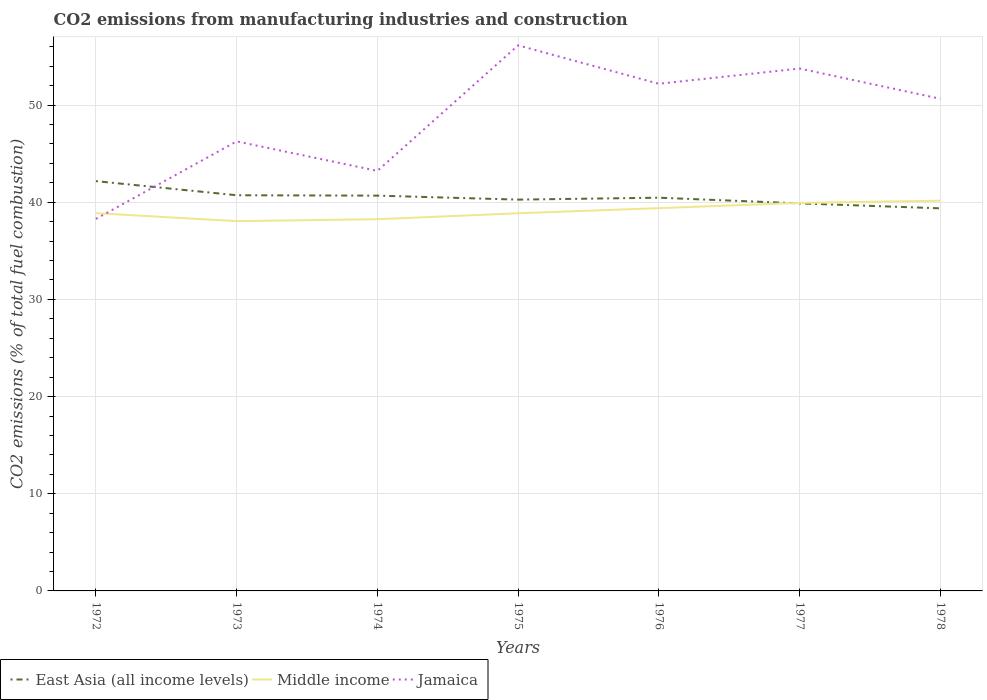How many different coloured lines are there?
Your answer should be very brief. 3. Across all years, what is the maximum amount of CO2 emitted in East Asia (all income levels)?
Offer a terse response. 39.37. In which year was the amount of CO2 emitted in East Asia (all income levels) maximum?
Give a very brief answer. 1978. What is the total amount of CO2 emitted in East Asia (all income levels) in the graph?
Your response must be concise. 0.45. What is the difference between the highest and the second highest amount of CO2 emitted in Jamaica?
Provide a short and direct response. 17.86. What is the difference between the highest and the lowest amount of CO2 emitted in Middle income?
Offer a very short reply. 3. Is the amount of CO2 emitted in Jamaica strictly greater than the amount of CO2 emitted in East Asia (all income levels) over the years?
Make the answer very short. No. How many years are there in the graph?
Ensure brevity in your answer.  7. What is the difference between two consecutive major ticks on the Y-axis?
Make the answer very short. 10. Are the values on the major ticks of Y-axis written in scientific E-notation?
Offer a terse response. No. Does the graph contain grids?
Your response must be concise. Yes. How are the legend labels stacked?
Offer a very short reply. Horizontal. What is the title of the graph?
Ensure brevity in your answer.  CO2 emissions from manufacturing industries and construction. Does "France" appear as one of the legend labels in the graph?
Provide a succinct answer. No. What is the label or title of the Y-axis?
Offer a terse response. CO2 emissions (% of total fuel combustion). What is the CO2 emissions (% of total fuel combustion) of East Asia (all income levels) in 1972?
Offer a terse response. 42.17. What is the CO2 emissions (% of total fuel combustion) in Middle income in 1972?
Give a very brief answer. 38.87. What is the CO2 emissions (% of total fuel combustion) of Jamaica in 1972?
Give a very brief answer. 38.28. What is the CO2 emissions (% of total fuel combustion) in East Asia (all income levels) in 1973?
Provide a short and direct response. 40.72. What is the CO2 emissions (% of total fuel combustion) in Middle income in 1973?
Provide a short and direct response. 38.05. What is the CO2 emissions (% of total fuel combustion) of Jamaica in 1973?
Offer a very short reply. 46.26. What is the CO2 emissions (% of total fuel combustion) in East Asia (all income levels) in 1974?
Your answer should be compact. 40.68. What is the CO2 emissions (% of total fuel combustion) in Middle income in 1974?
Offer a terse response. 38.25. What is the CO2 emissions (% of total fuel combustion) in Jamaica in 1974?
Make the answer very short. 43.22. What is the CO2 emissions (% of total fuel combustion) in East Asia (all income levels) in 1975?
Provide a succinct answer. 40.27. What is the CO2 emissions (% of total fuel combustion) of Middle income in 1975?
Keep it short and to the point. 38.86. What is the CO2 emissions (% of total fuel combustion) in Jamaica in 1975?
Ensure brevity in your answer.  56.14. What is the CO2 emissions (% of total fuel combustion) in East Asia (all income levels) in 1976?
Provide a short and direct response. 40.46. What is the CO2 emissions (% of total fuel combustion) in Middle income in 1976?
Ensure brevity in your answer.  39.39. What is the CO2 emissions (% of total fuel combustion) of Jamaica in 1976?
Your answer should be compact. 52.19. What is the CO2 emissions (% of total fuel combustion) in East Asia (all income levels) in 1977?
Offer a very short reply. 39.88. What is the CO2 emissions (% of total fuel combustion) of Middle income in 1977?
Offer a very short reply. 39.93. What is the CO2 emissions (% of total fuel combustion) of Jamaica in 1977?
Provide a succinct answer. 53.76. What is the CO2 emissions (% of total fuel combustion) of East Asia (all income levels) in 1978?
Keep it short and to the point. 39.37. What is the CO2 emissions (% of total fuel combustion) of Middle income in 1978?
Your response must be concise. 40.16. What is the CO2 emissions (% of total fuel combustion) of Jamaica in 1978?
Provide a short and direct response. 50.65. Across all years, what is the maximum CO2 emissions (% of total fuel combustion) of East Asia (all income levels)?
Make the answer very short. 42.17. Across all years, what is the maximum CO2 emissions (% of total fuel combustion) in Middle income?
Give a very brief answer. 40.16. Across all years, what is the maximum CO2 emissions (% of total fuel combustion) in Jamaica?
Offer a very short reply. 56.14. Across all years, what is the minimum CO2 emissions (% of total fuel combustion) in East Asia (all income levels)?
Keep it short and to the point. 39.37. Across all years, what is the minimum CO2 emissions (% of total fuel combustion) of Middle income?
Keep it short and to the point. 38.05. Across all years, what is the minimum CO2 emissions (% of total fuel combustion) of Jamaica?
Your response must be concise. 38.28. What is the total CO2 emissions (% of total fuel combustion) in East Asia (all income levels) in the graph?
Make the answer very short. 283.55. What is the total CO2 emissions (% of total fuel combustion) in Middle income in the graph?
Your answer should be compact. 273.51. What is the total CO2 emissions (% of total fuel combustion) of Jamaica in the graph?
Keep it short and to the point. 340.5. What is the difference between the CO2 emissions (% of total fuel combustion) of East Asia (all income levels) in 1972 and that in 1973?
Provide a short and direct response. 1.45. What is the difference between the CO2 emissions (% of total fuel combustion) in Middle income in 1972 and that in 1973?
Keep it short and to the point. 0.82. What is the difference between the CO2 emissions (% of total fuel combustion) in Jamaica in 1972 and that in 1973?
Offer a terse response. -7.98. What is the difference between the CO2 emissions (% of total fuel combustion) in East Asia (all income levels) in 1972 and that in 1974?
Offer a very short reply. 1.49. What is the difference between the CO2 emissions (% of total fuel combustion) of Middle income in 1972 and that in 1974?
Your answer should be very brief. 0.62. What is the difference between the CO2 emissions (% of total fuel combustion) of Jamaica in 1972 and that in 1974?
Your response must be concise. -4.94. What is the difference between the CO2 emissions (% of total fuel combustion) of East Asia (all income levels) in 1972 and that in 1975?
Offer a terse response. 1.9. What is the difference between the CO2 emissions (% of total fuel combustion) of Middle income in 1972 and that in 1975?
Make the answer very short. 0.01. What is the difference between the CO2 emissions (% of total fuel combustion) in Jamaica in 1972 and that in 1975?
Ensure brevity in your answer.  -17.86. What is the difference between the CO2 emissions (% of total fuel combustion) in East Asia (all income levels) in 1972 and that in 1976?
Your answer should be very brief. 1.7. What is the difference between the CO2 emissions (% of total fuel combustion) in Middle income in 1972 and that in 1976?
Ensure brevity in your answer.  -0.52. What is the difference between the CO2 emissions (% of total fuel combustion) in Jamaica in 1972 and that in 1976?
Provide a short and direct response. -13.9. What is the difference between the CO2 emissions (% of total fuel combustion) in East Asia (all income levels) in 1972 and that in 1977?
Your response must be concise. 2.29. What is the difference between the CO2 emissions (% of total fuel combustion) of Middle income in 1972 and that in 1977?
Offer a very short reply. -1.06. What is the difference between the CO2 emissions (% of total fuel combustion) in Jamaica in 1972 and that in 1977?
Your response must be concise. -15.47. What is the difference between the CO2 emissions (% of total fuel combustion) of East Asia (all income levels) in 1972 and that in 1978?
Provide a short and direct response. 2.8. What is the difference between the CO2 emissions (% of total fuel combustion) in Middle income in 1972 and that in 1978?
Offer a very short reply. -1.29. What is the difference between the CO2 emissions (% of total fuel combustion) in Jamaica in 1972 and that in 1978?
Offer a very short reply. -12.36. What is the difference between the CO2 emissions (% of total fuel combustion) in East Asia (all income levels) in 1973 and that in 1974?
Keep it short and to the point. 0.04. What is the difference between the CO2 emissions (% of total fuel combustion) of Middle income in 1973 and that in 1974?
Provide a short and direct response. -0.2. What is the difference between the CO2 emissions (% of total fuel combustion) of Jamaica in 1973 and that in 1974?
Provide a succinct answer. 3.03. What is the difference between the CO2 emissions (% of total fuel combustion) in East Asia (all income levels) in 1973 and that in 1975?
Provide a succinct answer. 0.45. What is the difference between the CO2 emissions (% of total fuel combustion) in Middle income in 1973 and that in 1975?
Give a very brief answer. -0.81. What is the difference between the CO2 emissions (% of total fuel combustion) in Jamaica in 1973 and that in 1975?
Your answer should be compact. -9.88. What is the difference between the CO2 emissions (% of total fuel combustion) of East Asia (all income levels) in 1973 and that in 1976?
Give a very brief answer. 0.25. What is the difference between the CO2 emissions (% of total fuel combustion) in Middle income in 1973 and that in 1976?
Your response must be concise. -1.34. What is the difference between the CO2 emissions (% of total fuel combustion) in Jamaica in 1973 and that in 1976?
Give a very brief answer. -5.93. What is the difference between the CO2 emissions (% of total fuel combustion) in East Asia (all income levels) in 1973 and that in 1977?
Offer a terse response. 0.84. What is the difference between the CO2 emissions (% of total fuel combustion) in Middle income in 1973 and that in 1977?
Offer a very short reply. -1.88. What is the difference between the CO2 emissions (% of total fuel combustion) of Jamaica in 1973 and that in 1977?
Give a very brief answer. -7.5. What is the difference between the CO2 emissions (% of total fuel combustion) in East Asia (all income levels) in 1973 and that in 1978?
Keep it short and to the point. 1.35. What is the difference between the CO2 emissions (% of total fuel combustion) of Middle income in 1973 and that in 1978?
Make the answer very short. -2.1. What is the difference between the CO2 emissions (% of total fuel combustion) in Jamaica in 1973 and that in 1978?
Provide a succinct answer. -4.39. What is the difference between the CO2 emissions (% of total fuel combustion) of East Asia (all income levels) in 1974 and that in 1975?
Provide a short and direct response. 0.41. What is the difference between the CO2 emissions (% of total fuel combustion) in Middle income in 1974 and that in 1975?
Offer a terse response. -0.61. What is the difference between the CO2 emissions (% of total fuel combustion) in Jamaica in 1974 and that in 1975?
Give a very brief answer. -12.92. What is the difference between the CO2 emissions (% of total fuel combustion) in East Asia (all income levels) in 1974 and that in 1976?
Your response must be concise. 0.21. What is the difference between the CO2 emissions (% of total fuel combustion) in Middle income in 1974 and that in 1976?
Your response must be concise. -1.14. What is the difference between the CO2 emissions (% of total fuel combustion) in Jamaica in 1974 and that in 1976?
Offer a terse response. -8.96. What is the difference between the CO2 emissions (% of total fuel combustion) in East Asia (all income levels) in 1974 and that in 1977?
Ensure brevity in your answer.  0.8. What is the difference between the CO2 emissions (% of total fuel combustion) of Middle income in 1974 and that in 1977?
Give a very brief answer. -1.68. What is the difference between the CO2 emissions (% of total fuel combustion) of Jamaica in 1974 and that in 1977?
Offer a terse response. -10.53. What is the difference between the CO2 emissions (% of total fuel combustion) in East Asia (all income levels) in 1974 and that in 1978?
Provide a succinct answer. 1.3. What is the difference between the CO2 emissions (% of total fuel combustion) of Middle income in 1974 and that in 1978?
Your response must be concise. -1.91. What is the difference between the CO2 emissions (% of total fuel combustion) in Jamaica in 1974 and that in 1978?
Give a very brief answer. -7.42. What is the difference between the CO2 emissions (% of total fuel combustion) of East Asia (all income levels) in 1975 and that in 1976?
Your answer should be very brief. -0.2. What is the difference between the CO2 emissions (% of total fuel combustion) of Middle income in 1975 and that in 1976?
Make the answer very short. -0.53. What is the difference between the CO2 emissions (% of total fuel combustion) in Jamaica in 1975 and that in 1976?
Ensure brevity in your answer.  3.95. What is the difference between the CO2 emissions (% of total fuel combustion) in East Asia (all income levels) in 1975 and that in 1977?
Offer a very short reply. 0.39. What is the difference between the CO2 emissions (% of total fuel combustion) in Middle income in 1975 and that in 1977?
Your response must be concise. -1.07. What is the difference between the CO2 emissions (% of total fuel combustion) of Jamaica in 1975 and that in 1977?
Offer a terse response. 2.38. What is the difference between the CO2 emissions (% of total fuel combustion) in East Asia (all income levels) in 1975 and that in 1978?
Offer a terse response. 0.9. What is the difference between the CO2 emissions (% of total fuel combustion) of Middle income in 1975 and that in 1978?
Keep it short and to the point. -1.3. What is the difference between the CO2 emissions (% of total fuel combustion) of Jamaica in 1975 and that in 1978?
Offer a terse response. 5.49. What is the difference between the CO2 emissions (% of total fuel combustion) in East Asia (all income levels) in 1976 and that in 1977?
Ensure brevity in your answer.  0.58. What is the difference between the CO2 emissions (% of total fuel combustion) in Middle income in 1976 and that in 1977?
Your response must be concise. -0.54. What is the difference between the CO2 emissions (% of total fuel combustion) of Jamaica in 1976 and that in 1977?
Your answer should be compact. -1.57. What is the difference between the CO2 emissions (% of total fuel combustion) in East Asia (all income levels) in 1976 and that in 1978?
Your response must be concise. 1.09. What is the difference between the CO2 emissions (% of total fuel combustion) of Middle income in 1976 and that in 1978?
Give a very brief answer. -0.77. What is the difference between the CO2 emissions (% of total fuel combustion) in Jamaica in 1976 and that in 1978?
Give a very brief answer. 1.54. What is the difference between the CO2 emissions (% of total fuel combustion) in East Asia (all income levels) in 1977 and that in 1978?
Your answer should be very brief. 0.51. What is the difference between the CO2 emissions (% of total fuel combustion) in Middle income in 1977 and that in 1978?
Give a very brief answer. -0.23. What is the difference between the CO2 emissions (% of total fuel combustion) of Jamaica in 1977 and that in 1978?
Provide a short and direct response. 3.11. What is the difference between the CO2 emissions (% of total fuel combustion) of East Asia (all income levels) in 1972 and the CO2 emissions (% of total fuel combustion) of Middle income in 1973?
Your answer should be compact. 4.12. What is the difference between the CO2 emissions (% of total fuel combustion) of East Asia (all income levels) in 1972 and the CO2 emissions (% of total fuel combustion) of Jamaica in 1973?
Your response must be concise. -4.09. What is the difference between the CO2 emissions (% of total fuel combustion) in Middle income in 1972 and the CO2 emissions (% of total fuel combustion) in Jamaica in 1973?
Ensure brevity in your answer.  -7.39. What is the difference between the CO2 emissions (% of total fuel combustion) in East Asia (all income levels) in 1972 and the CO2 emissions (% of total fuel combustion) in Middle income in 1974?
Give a very brief answer. 3.92. What is the difference between the CO2 emissions (% of total fuel combustion) of East Asia (all income levels) in 1972 and the CO2 emissions (% of total fuel combustion) of Jamaica in 1974?
Make the answer very short. -1.06. What is the difference between the CO2 emissions (% of total fuel combustion) of Middle income in 1972 and the CO2 emissions (% of total fuel combustion) of Jamaica in 1974?
Offer a terse response. -4.35. What is the difference between the CO2 emissions (% of total fuel combustion) of East Asia (all income levels) in 1972 and the CO2 emissions (% of total fuel combustion) of Middle income in 1975?
Keep it short and to the point. 3.31. What is the difference between the CO2 emissions (% of total fuel combustion) in East Asia (all income levels) in 1972 and the CO2 emissions (% of total fuel combustion) in Jamaica in 1975?
Your response must be concise. -13.97. What is the difference between the CO2 emissions (% of total fuel combustion) of Middle income in 1972 and the CO2 emissions (% of total fuel combustion) of Jamaica in 1975?
Give a very brief answer. -17.27. What is the difference between the CO2 emissions (% of total fuel combustion) in East Asia (all income levels) in 1972 and the CO2 emissions (% of total fuel combustion) in Middle income in 1976?
Make the answer very short. 2.78. What is the difference between the CO2 emissions (% of total fuel combustion) in East Asia (all income levels) in 1972 and the CO2 emissions (% of total fuel combustion) in Jamaica in 1976?
Offer a terse response. -10.02. What is the difference between the CO2 emissions (% of total fuel combustion) in Middle income in 1972 and the CO2 emissions (% of total fuel combustion) in Jamaica in 1976?
Offer a very short reply. -13.32. What is the difference between the CO2 emissions (% of total fuel combustion) in East Asia (all income levels) in 1972 and the CO2 emissions (% of total fuel combustion) in Middle income in 1977?
Give a very brief answer. 2.24. What is the difference between the CO2 emissions (% of total fuel combustion) in East Asia (all income levels) in 1972 and the CO2 emissions (% of total fuel combustion) in Jamaica in 1977?
Ensure brevity in your answer.  -11.59. What is the difference between the CO2 emissions (% of total fuel combustion) in Middle income in 1972 and the CO2 emissions (% of total fuel combustion) in Jamaica in 1977?
Provide a short and direct response. -14.88. What is the difference between the CO2 emissions (% of total fuel combustion) in East Asia (all income levels) in 1972 and the CO2 emissions (% of total fuel combustion) in Middle income in 1978?
Provide a succinct answer. 2.01. What is the difference between the CO2 emissions (% of total fuel combustion) of East Asia (all income levels) in 1972 and the CO2 emissions (% of total fuel combustion) of Jamaica in 1978?
Make the answer very short. -8.48. What is the difference between the CO2 emissions (% of total fuel combustion) in Middle income in 1972 and the CO2 emissions (% of total fuel combustion) in Jamaica in 1978?
Make the answer very short. -11.78. What is the difference between the CO2 emissions (% of total fuel combustion) in East Asia (all income levels) in 1973 and the CO2 emissions (% of total fuel combustion) in Middle income in 1974?
Provide a succinct answer. 2.47. What is the difference between the CO2 emissions (% of total fuel combustion) in East Asia (all income levels) in 1973 and the CO2 emissions (% of total fuel combustion) in Jamaica in 1974?
Give a very brief answer. -2.51. What is the difference between the CO2 emissions (% of total fuel combustion) in Middle income in 1973 and the CO2 emissions (% of total fuel combustion) in Jamaica in 1974?
Keep it short and to the point. -5.17. What is the difference between the CO2 emissions (% of total fuel combustion) of East Asia (all income levels) in 1973 and the CO2 emissions (% of total fuel combustion) of Middle income in 1975?
Provide a short and direct response. 1.86. What is the difference between the CO2 emissions (% of total fuel combustion) in East Asia (all income levels) in 1973 and the CO2 emissions (% of total fuel combustion) in Jamaica in 1975?
Ensure brevity in your answer.  -15.42. What is the difference between the CO2 emissions (% of total fuel combustion) in Middle income in 1973 and the CO2 emissions (% of total fuel combustion) in Jamaica in 1975?
Keep it short and to the point. -18.09. What is the difference between the CO2 emissions (% of total fuel combustion) of East Asia (all income levels) in 1973 and the CO2 emissions (% of total fuel combustion) of Middle income in 1976?
Give a very brief answer. 1.33. What is the difference between the CO2 emissions (% of total fuel combustion) in East Asia (all income levels) in 1973 and the CO2 emissions (% of total fuel combustion) in Jamaica in 1976?
Make the answer very short. -11.47. What is the difference between the CO2 emissions (% of total fuel combustion) in Middle income in 1973 and the CO2 emissions (% of total fuel combustion) in Jamaica in 1976?
Provide a succinct answer. -14.14. What is the difference between the CO2 emissions (% of total fuel combustion) in East Asia (all income levels) in 1973 and the CO2 emissions (% of total fuel combustion) in Middle income in 1977?
Provide a short and direct response. 0.79. What is the difference between the CO2 emissions (% of total fuel combustion) in East Asia (all income levels) in 1973 and the CO2 emissions (% of total fuel combustion) in Jamaica in 1977?
Ensure brevity in your answer.  -13.04. What is the difference between the CO2 emissions (% of total fuel combustion) in Middle income in 1973 and the CO2 emissions (% of total fuel combustion) in Jamaica in 1977?
Provide a short and direct response. -15.7. What is the difference between the CO2 emissions (% of total fuel combustion) in East Asia (all income levels) in 1973 and the CO2 emissions (% of total fuel combustion) in Middle income in 1978?
Make the answer very short. 0.56. What is the difference between the CO2 emissions (% of total fuel combustion) of East Asia (all income levels) in 1973 and the CO2 emissions (% of total fuel combustion) of Jamaica in 1978?
Keep it short and to the point. -9.93. What is the difference between the CO2 emissions (% of total fuel combustion) in Middle income in 1973 and the CO2 emissions (% of total fuel combustion) in Jamaica in 1978?
Offer a very short reply. -12.59. What is the difference between the CO2 emissions (% of total fuel combustion) in East Asia (all income levels) in 1974 and the CO2 emissions (% of total fuel combustion) in Middle income in 1975?
Keep it short and to the point. 1.81. What is the difference between the CO2 emissions (% of total fuel combustion) of East Asia (all income levels) in 1974 and the CO2 emissions (% of total fuel combustion) of Jamaica in 1975?
Give a very brief answer. -15.46. What is the difference between the CO2 emissions (% of total fuel combustion) in Middle income in 1974 and the CO2 emissions (% of total fuel combustion) in Jamaica in 1975?
Provide a succinct answer. -17.89. What is the difference between the CO2 emissions (% of total fuel combustion) of East Asia (all income levels) in 1974 and the CO2 emissions (% of total fuel combustion) of Middle income in 1976?
Your response must be concise. 1.29. What is the difference between the CO2 emissions (% of total fuel combustion) of East Asia (all income levels) in 1974 and the CO2 emissions (% of total fuel combustion) of Jamaica in 1976?
Your answer should be compact. -11.51. What is the difference between the CO2 emissions (% of total fuel combustion) of Middle income in 1974 and the CO2 emissions (% of total fuel combustion) of Jamaica in 1976?
Offer a very short reply. -13.94. What is the difference between the CO2 emissions (% of total fuel combustion) of East Asia (all income levels) in 1974 and the CO2 emissions (% of total fuel combustion) of Middle income in 1977?
Offer a terse response. 0.75. What is the difference between the CO2 emissions (% of total fuel combustion) in East Asia (all income levels) in 1974 and the CO2 emissions (% of total fuel combustion) in Jamaica in 1977?
Your response must be concise. -13.08. What is the difference between the CO2 emissions (% of total fuel combustion) in Middle income in 1974 and the CO2 emissions (% of total fuel combustion) in Jamaica in 1977?
Offer a very short reply. -15.5. What is the difference between the CO2 emissions (% of total fuel combustion) in East Asia (all income levels) in 1974 and the CO2 emissions (% of total fuel combustion) in Middle income in 1978?
Offer a very short reply. 0.52. What is the difference between the CO2 emissions (% of total fuel combustion) of East Asia (all income levels) in 1974 and the CO2 emissions (% of total fuel combustion) of Jamaica in 1978?
Ensure brevity in your answer.  -9.97. What is the difference between the CO2 emissions (% of total fuel combustion) of Middle income in 1974 and the CO2 emissions (% of total fuel combustion) of Jamaica in 1978?
Keep it short and to the point. -12.4. What is the difference between the CO2 emissions (% of total fuel combustion) of East Asia (all income levels) in 1975 and the CO2 emissions (% of total fuel combustion) of Middle income in 1976?
Offer a very short reply. 0.88. What is the difference between the CO2 emissions (% of total fuel combustion) in East Asia (all income levels) in 1975 and the CO2 emissions (% of total fuel combustion) in Jamaica in 1976?
Offer a terse response. -11.92. What is the difference between the CO2 emissions (% of total fuel combustion) in Middle income in 1975 and the CO2 emissions (% of total fuel combustion) in Jamaica in 1976?
Offer a very short reply. -13.33. What is the difference between the CO2 emissions (% of total fuel combustion) in East Asia (all income levels) in 1975 and the CO2 emissions (% of total fuel combustion) in Middle income in 1977?
Keep it short and to the point. 0.34. What is the difference between the CO2 emissions (% of total fuel combustion) of East Asia (all income levels) in 1975 and the CO2 emissions (% of total fuel combustion) of Jamaica in 1977?
Your answer should be compact. -13.49. What is the difference between the CO2 emissions (% of total fuel combustion) of Middle income in 1975 and the CO2 emissions (% of total fuel combustion) of Jamaica in 1977?
Provide a short and direct response. -14.89. What is the difference between the CO2 emissions (% of total fuel combustion) in East Asia (all income levels) in 1975 and the CO2 emissions (% of total fuel combustion) in Middle income in 1978?
Offer a very short reply. 0.11. What is the difference between the CO2 emissions (% of total fuel combustion) of East Asia (all income levels) in 1975 and the CO2 emissions (% of total fuel combustion) of Jamaica in 1978?
Ensure brevity in your answer.  -10.38. What is the difference between the CO2 emissions (% of total fuel combustion) in Middle income in 1975 and the CO2 emissions (% of total fuel combustion) in Jamaica in 1978?
Provide a succinct answer. -11.79. What is the difference between the CO2 emissions (% of total fuel combustion) in East Asia (all income levels) in 1976 and the CO2 emissions (% of total fuel combustion) in Middle income in 1977?
Offer a very short reply. 0.53. What is the difference between the CO2 emissions (% of total fuel combustion) in East Asia (all income levels) in 1976 and the CO2 emissions (% of total fuel combustion) in Jamaica in 1977?
Give a very brief answer. -13.29. What is the difference between the CO2 emissions (% of total fuel combustion) in Middle income in 1976 and the CO2 emissions (% of total fuel combustion) in Jamaica in 1977?
Your answer should be compact. -14.37. What is the difference between the CO2 emissions (% of total fuel combustion) in East Asia (all income levels) in 1976 and the CO2 emissions (% of total fuel combustion) in Middle income in 1978?
Offer a very short reply. 0.31. What is the difference between the CO2 emissions (% of total fuel combustion) of East Asia (all income levels) in 1976 and the CO2 emissions (% of total fuel combustion) of Jamaica in 1978?
Your answer should be compact. -10.18. What is the difference between the CO2 emissions (% of total fuel combustion) of Middle income in 1976 and the CO2 emissions (% of total fuel combustion) of Jamaica in 1978?
Give a very brief answer. -11.26. What is the difference between the CO2 emissions (% of total fuel combustion) in East Asia (all income levels) in 1977 and the CO2 emissions (% of total fuel combustion) in Middle income in 1978?
Ensure brevity in your answer.  -0.28. What is the difference between the CO2 emissions (% of total fuel combustion) in East Asia (all income levels) in 1977 and the CO2 emissions (% of total fuel combustion) in Jamaica in 1978?
Your answer should be compact. -10.77. What is the difference between the CO2 emissions (% of total fuel combustion) in Middle income in 1977 and the CO2 emissions (% of total fuel combustion) in Jamaica in 1978?
Your response must be concise. -10.72. What is the average CO2 emissions (% of total fuel combustion) of East Asia (all income levels) per year?
Offer a very short reply. 40.51. What is the average CO2 emissions (% of total fuel combustion) in Middle income per year?
Keep it short and to the point. 39.07. What is the average CO2 emissions (% of total fuel combustion) of Jamaica per year?
Keep it short and to the point. 48.64. In the year 1972, what is the difference between the CO2 emissions (% of total fuel combustion) in East Asia (all income levels) and CO2 emissions (% of total fuel combustion) in Middle income?
Provide a short and direct response. 3.3. In the year 1972, what is the difference between the CO2 emissions (% of total fuel combustion) in East Asia (all income levels) and CO2 emissions (% of total fuel combustion) in Jamaica?
Make the answer very short. 3.88. In the year 1972, what is the difference between the CO2 emissions (% of total fuel combustion) of Middle income and CO2 emissions (% of total fuel combustion) of Jamaica?
Keep it short and to the point. 0.59. In the year 1973, what is the difference between the CO2 emissions (% of total fuel combustion) in East Asia (all income levels) and CO2 emissions (% of total fuel combustion) in Middle income?
Provide a succinct answer. 2.67. In the year 1973, what is the difference between the CO2 emissions (% of total fuel combustion) of East Asia (all income levels) and CO2 emissions (% of total fuel combustion) of Jamaica?
Offer a very short reply. -5.54. In the year 1973, what is the difference between the CO2 emissions (% of total fuel combustion) in Middle income and CO2 emissions (% of total fuel combustion) in Jamaica?
Provide a succinct answer. -8.21. In the year 1974, what is the difference between the CO2 emissions (% of total fuel combustion) of East Asia (all income levels) and CO2 emissions (% of total fuel combustion) of Middle income?
Provide a short and direct response. 2.43. In the year 1974, what is the difference between the CO2 emissions (% of total fuel combustion) in East Asia (all income levels) and CO2 emissions (% of total fuel combustion) in Jamaica?
Keep it short and to the point. -2.55. In the year 1974, what is the difference between the CO2 emissions (% of total fuel combustion) of Middle income and CO2 emissions (% of total fuel combustion) of Jamaica?
Ensure brevity in your answer.  -4.97. In the year 1975, what is the difference between the CO2 emissions (% of total fuel combustion) in East Asia (all income levels) and CO2 emissions (% of total fuel combustion) in Middle income?
Your answer should be very brief. 1.41. In the year 1975, what is the difference between the CO2 emissions (% of total fuel combustion) of East Asia (all income levels) and CO2 emissions (% of total fuel combustion) of Jamaica?
Your answer should be very brief. -15.87. In the year 1975, what is the difference between the CO2 emissions (% of total fuel combustion) of Middle income and CO2 emissions (% of total fuel combustion) of Jamaica?
Offer a very short reply. -17.28. In the year 1976, what is the difference between the CO2 emissions (% of total fuel combustion) in East Asia (all income levels) and CO2 emissions (% of total fuel combustion) in Middle income?
Offer a very short reply. 1.07. In the year 1976, what is the difference between the CO2 emissions (% of total fuel combustion) in East Asia (all income levels) and CO2 emissions (% of total fuel combustion) in Jamaica?
Keep it short and to the point. -11.72. In the year 1976, what is the difference between the CO2 emissions (% of total fuel combustion) in Middle income and CO2 emissions (% of total fuel combustion) in Jamaica?
Provide a succinct answer. -12.8. In the year 1977, what is the difference between the CO2 emissions (% of total fuel combustion) of East Asia (all income levels) and CO2 emissions (% of total fuel combustion) of Middle income?
Offer a terse response. -0.05. In the year 1977, what is the difference between the CO2 emissions (% of total fuel combustion) of East Asia (all income levels) and CO2 emissions (% of total fuel combustion) of Jamaica?
Your answer should be compact. -13.87. In the year 1977, what is the difference between the CO2 emissions (% of total fuel combustion) in Middle income and CO2 emissions (% of total fuel combustion) in Jamaica?
Your answer should be compact. -13.83. In the year 1978, what is the difference between the CO2 emissions (% of total fuel combustion) in East Asia (all income levels) and CO2 emissions (% of total fuel combustion) in Middle income?
Ensure brevity in your answer.  -0.79. In the year 1978, what is the difference between the CO2 emissions (% of total fuel combustion) in East Asia (all income levels) and CO2 emissions (% of total fuel combustion) in Jamaica?
Your answer should be compact. -11.28. In the year 1978, what is the difference between the CO2 emissions (% of total fuel combustion) in Middle income and CO2 emissions (% of total fuel combustion) in Jamaica?
Your response must be concise. -10.49. What is the ratio of the CO2 emissions (% of total fuel combustion) in East Asia (all income levels) in 1972 to that in 1973?
Give a very brief answer. 1.04. What is the ratio of the CO2 emissions (% of total fuel combustion) of Middle income in 1972 to that in 1973?
Provide a short and direct response. 1.02. What is the ratio of the CO2 emissions (% of total fuel combustion) of Jamaica in 1972 to that in 1973?
Keep it short and to the point. 0.83. What is the ratio of the CO2 emissions (% of total fuel combustion) in East Asia (all income levels) in 1972 to that in 1974?
Your response must be concise. 1.04. What is the ratio of the CO2 emissions (% of total fuel combustion) of Middle income in 1972 to that in 1974?
Your response must be concise. 1.02. What is the ratio of the CO2 emissions (% of total fuel combustion) in Jamaica in 1972 to that in 1974?
Provide a succinct answer. 0.89. What is the ratio of the CO2 emissions (% of total fuel combustion) of East Asia (all income levels) in 1972 to that in 1975?
Give a very brief answer. 1.05. What is the ratio of the CO2 emissions (% of total fuel combustion) of Middle income in 1972 to that in 1975?
Provide a succinct answer. 1. What is the ratio of the CO2 emissions (% of total fuel combustion) of Jamaica in 1972 to that in 1975?
Give a very brief answer. 0.68. What is the ratio of the CO2 emissions (% of total fuel combustion) in East Asia (all income levels) in 1972 to that in 1976?
Provide a succinct answer. 1.04. What is the ratio of the CO2 emissions (% of total fuel combustion) in Middle income in 1972 to that in 1976?
Ensure brevity in your answer.  0.99. What is the ratio of the CO2 emissions (% of total fuel combustion) of Jamaica in 1972 to that in 1976?
Provide a short and direct response. 0.73. What is the ratio of the CO2 emissions (% of total fuel combustion) in East Asia (all income levels) in 1972 to that in 1977?
Keep it short and to the point. 1.06. What is the ratio of the CO2 emissions (% of total fuel combustion) in Middle income in 1972 to that in 1977?
Your response must be concise. 0.97. What is the ratio of the CO2 emissions (% of total fuel combustion) of Jamaica in 1972 to that in 1977?
Keep it short and to the point. 0.71. What is the ratio of the CO2 emissions (% of total fuel combustion) in East Asia (all income levels) in 1972 to that in 1978?
Ensure brevity in your answer.  1.07. What is the ratio of the CO2 emissions (% of total fuel combustion) of Jamaica in 1972 to that in 1978?
Offer a terse response. 0.76. What is the ratio of the CO2 emissions (% of total fuel combustion) in Middle income in 1973 to that in 1974?
Keep it short and to the point. 0.99. What is the ratio of the CO2 emissions (% of total fuel combustion) in Jamaica in 1973 to that in 1974?
Your answer should be compact. 1.07. What is the ratio of the CO2 emissions (% of total fuel combustion) in East Asia (all income levels) in 1973 to that in 1975?
Your response must be concise. 1.01. What is the ratio of the CO2 emissions (% of total fuel combustion) of Middle income in 1973 to that in 1975?
Your answer should be very brief. 0.98. What is the ratio of the CO2 emissions (% of total fuel combustion) in Jamaica in 1973 to that in 1975?
Offer a terse response. 0.82. What is the ratio of the CO2 emissions (% of total fuel combustion) of Middle income in 1973 to that in 1976?
Your response must be concise. 0.97. What is the ratio of the CO2 emissions (% of total fuel combustion) in Jamaica in 1973 to that in 1976?
Ensure brevity in your answer.  0.89. What is the ratio of the CO2 emissions (% of total fuel combustion) in East Asia (all income levels) in 1973 to that in 1977?
Give a very brief answer. 1.02. What is the ratio of the CO2 emissions (% of total fuel combustion) of Middle income in 1973 to that in 1977?
Make the answer very short. 0.95. What is the ratio of the CO2 emissions (% of total fuel combustion) in Jamaica in 1973 to that in 1977?
Offer a terse response. 0.86. What is the ratio of the CO2 emissions (% of total fuel combustion) of East Asia (all income levels) in 1973 to that in 1978?
Offer a very short reply. 1.03. What is the ratio of the CO2 emissions (% of total fuel combustion) in Middle income in 1973 to that in 1978?
Give a very brief answer. 0.95. What is the ratio of the CO2 emissions (% of total fuel combustion) of Jamaica in 1973 to that in 1978?
Offer a very short reply. 0.91. What is the ratio of the CO2 emissions (% of total fuel combustion) in Middle income in 1974 to that in 1975?
Ensure brevity in your answer.  0.98. What is the ratio of the CO2 emissions (% of total fuel combustion) of Jamaica in 1974 to that in 1975?
Offer a very short reply. 0.77. What is the ratio of the CO2 emissions (% of total fuel combustion) of East Asia (all income levels) in 1974 to that in 1976?
Make the answer very short. 1.01. What is the ratio of the CO2 emissions (% of total fuel combustion) of Middle income in 1974 to that in 1976?
Keep it short and to the point. 0.97. What is the ratio of the CO2 emissions (% of total fuel combustion) in Jamaica in 1974 to that in 1976?
Ensure brevity in your answer.  0.83. What is the ratio of the CO2 emissions (% of total fuel combustion) in East Asia (all income levels) in 1974 to that in 1977?
Provide a short and direct response. 1.02. What is the ratio of the CO2 emissions (% of total fuel combustion) in Middle income in 1974 to that in 1977?
Provide a succinct answer. 0.96. What is the ratio of the CO2 emissions (% of total fuel combustion) of Jamaica in 1974 to that in 1977?
Offer a very short reply. 0.8. What is the ratio of the CO2 emissions (% of total fuel combustion) in East Asia (all income levels) in 1974 to that in 1978?
Offer a terse response. 1.03. What is the ratio of the CO2 emissions (% of total fuel combustion) in Middle income in 1974 to that in 1978?
Provide a short and direct response. 0.95. What is the ratio of the CO2 emissions (% of total fuel combustion) of Jamaica in 1974 to that in 1978?
Provide a succinct answer. 0.85. What is the ratio of the CO2 emissions (% of total fuel combustion) of East Asia (all income levels) in 1975 to that in 1976?
Ensure brevity in your answer.  1. What is the ratio of the CO2 emissions (% of total fuel combustion) in Middle income in 1975 to that in 1976?
Keep it short and to the point. 0.99. What is the ratio of the CO2 emissions (% of total fuel combustion) of Jamaica in 1975 to that in 1976?
Ensure brevity in your answer.  1.08. What is the ratio of the CO2 emissions (% of total fuel combustion) in East Asia (all income levels) in 1975 to that in 1977?
Ensure brevity in your answer.  1.01. What is the ratio of the CO2 emissions (% of total fuel combustion) of Middle income in 1975 to that in 1977?
Keep it short and to the point. 0.97. What is the ratio of the CO2 emissions (% of total fuel combustion) of Jamaica in 1975 to that in 1977?
Offer a very short reply. 1.04. What is the ratio of the CO2 emissions (% of total fuel combustion) of East Asia (all income levels) in 1975 to that in 1978?
Your response must be concise. 1.02. What is the ratio of the CO2 emissions (% of total fuel combustion) of Jamaica in 1975 to that in 1978?
Provide a succinct answer. 1.11. What is the ratio of the CO2 emissions (% of total fuel combustion) of East Asia (all income levels) in 1976 to that in 1977?
Ensure brevity in your answer.  1.01. What is the ratio of the CO2 emissions (% of total fuel combustion) of Middle income in 1976 to that in 1977?
Offer a terse response. 0.99. What is the ratio of the CO2 emissions (% of total fuel combustion) in Jamaica in 1976 to that in 1977?
Provide a short and direct response. 0.97. What is the ratio of the CO2 emissions (% of total fuel combustion) of East Asia (all income levels) in 1976 to that in 1978?
Offer a very short reply. 1.03. What is the ratio of the CO2 emissions (% of total fuel combustion) of Middle income in 1976 to that in 1978?
Offer a terse response. 0.98. What is the ratio of the CO2 emissions (% of total fuel combustion) of Jamaica in 1976 to that in 1978?
Your answer should be compact. 1.03. What is the ratio of the CO2 emissions (% of total fuel combustion) in East Asia (all income levels) in 1977 to that in 1978?
Offer a very short reply. 1.01. What is the ratio of the CO2 emissions (% of total fuel combustion) in Middle income in 1977 to that in 1978?
Your answer should be very brief. 0.99. What is the ratio of the CO2 emissions (% of total fuel combustion) in Jamaica in 1977 to that in 1978?
Keep it short and to the point. 1.06. What is the difference between the highest and the second highest CO2 emissions (% of total fuel combustion) in East Asia (all income levels)?
Provide a succinct answer. 1.45. What is the difference between the highest and the second highest CO2 emissions (% of total fuel combustion) in Middle income?
Offer a terse response. 0.23. What is the difference between the highest and the second highest CO2 emissions (% of total fuel combustion) in Jamaica?
Offer a very short reply. 2.38. What is the difference between the highest and the lowest CO2 emissions (% of total fuel combustion) of East Asia (all income levels)?
Provide a succinct answer. 2.8. What is the difference between the highest and the lowest CO2 emissions (% of total fuel combustion) of Middle income?
Your answer should be very brief. 2.1. What is the difference between the highest and the lowest CO2 emissions (% of total fuel combustion) in Jamaica?
Your answer should be very brief. 17.86. 